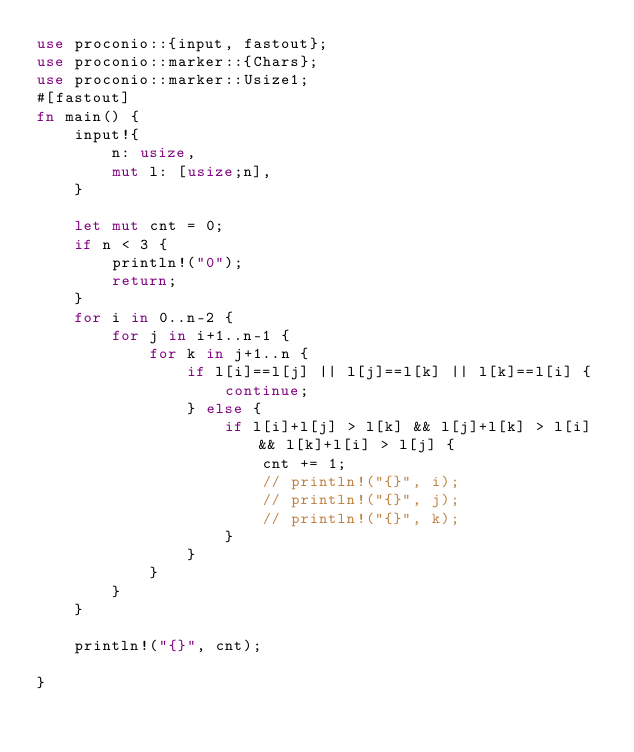Convert code to text. <code><loc_0><loc_0><loc_500><loc_500><_Rust_>use proconio::{input, fastout};
use proconio::marker::{Chars};
use proconio::marker::Usize1;
#[fastout]
fn main() {
    input!{
        n: usize,
        mut l: [usize;n],
    }
    
    let mut cnt = 0;
    if n < 3 {
        println!("0");
        return;
    }
    for i in 0..n-2 {
        for j in i+1..n-1 {
            for k in j+1..n {
                if l[i]==l[j] || l[j]==l[k] || l[k]==l[i] {
                    continue;
                } else {
                    if l[i]+l[j] > l[k] && l[j]+l[k] > l[i] && l[k]+l[i] > l[j] {
                        cnt += 1;
                        // println!("{}", i);
                        // println!("{}", j);
                        // println!("{}", k);
                    }
                }
            }
        }
    }

    println!("{}", cnt);

}
</code> 